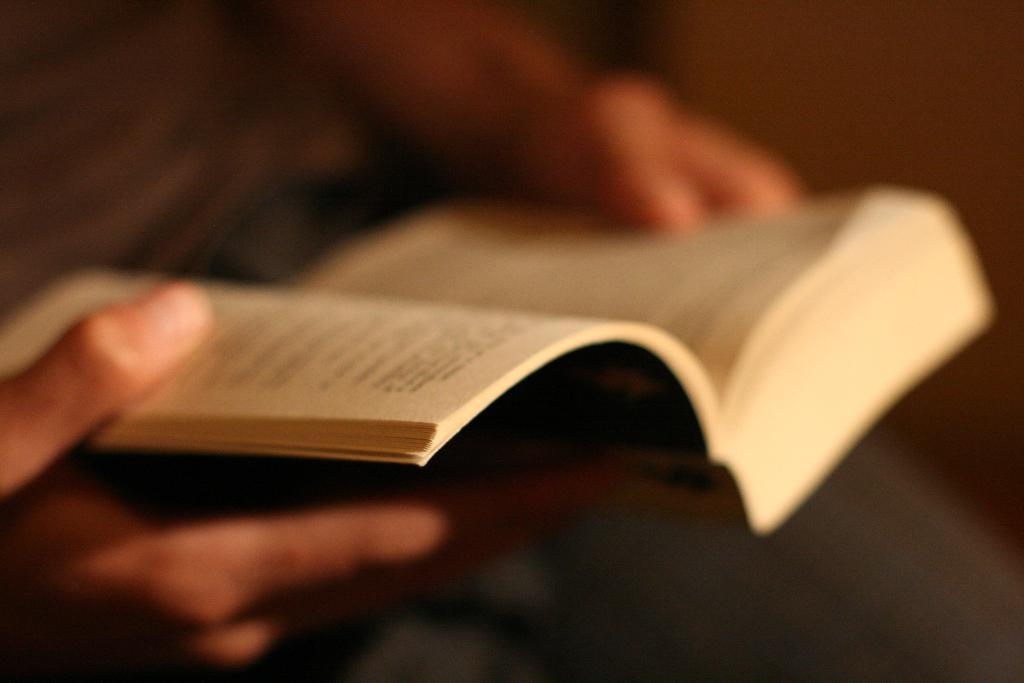Describe this image in one or two sentences. In this image there is a person holding a book. 